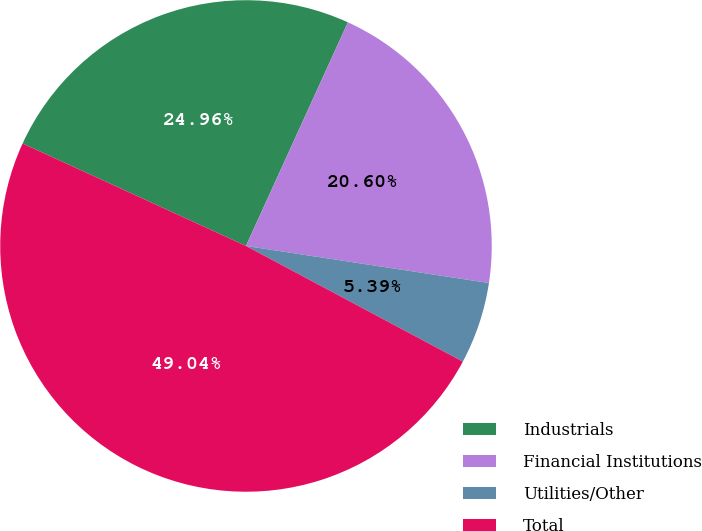Convert chart to OTSL. <chart><loc_0><loc_0><loc_500><loc_500><pie_chart><fcel>Industrials<fcel>Financial Institutions<fcel>Utilities/Other<fcel>Total<nl><fcel>24.96%<fcel>20.6%<fcel>5.39%<fcel>49.04%<nl></chart> 